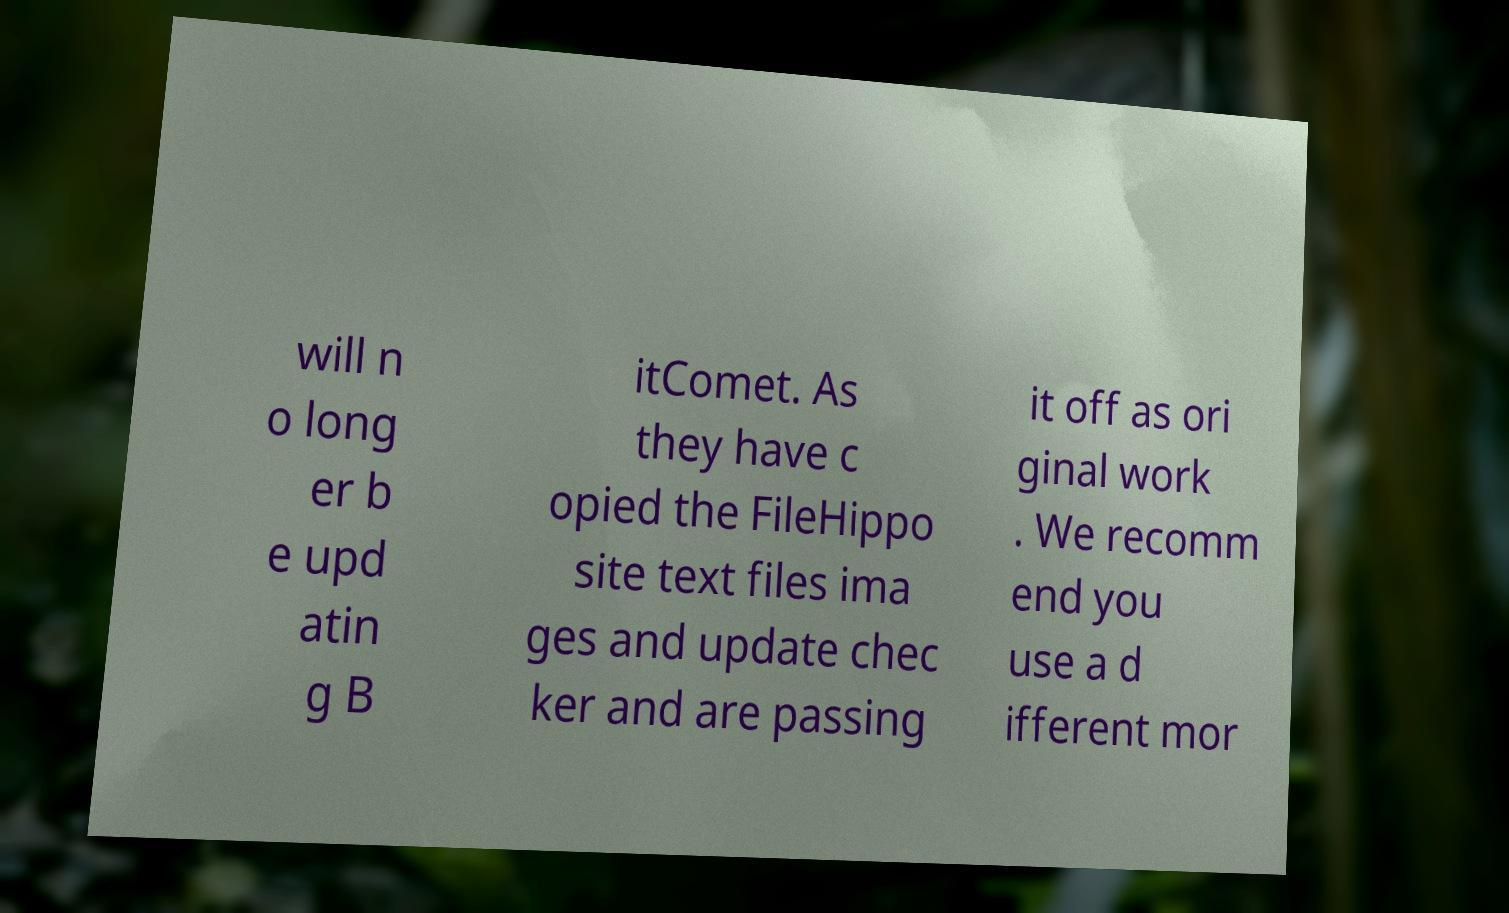There's text embedded in this image that I need extracted. Can you transcribe it verbatim? will n o long er b e upd atin g B itComet. As they have c opied the FileHippo site text files ima ges and update chec ker and are passing it off as ori ginal work . We recomm end you use a d ifferent mor 